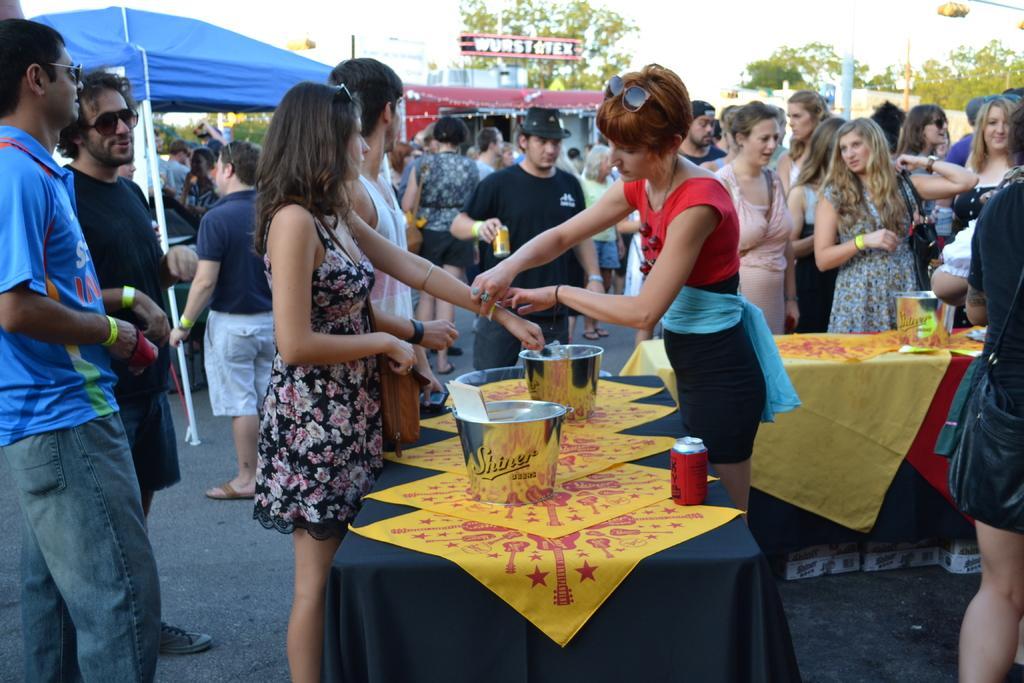Describe this image in one or two sentences. In this image in the front there is a table, on the table there are buckets and there is a tin can and there are persons standing and walking. In the background there is a tent which is blue in colour, there are trees, poles, there is a board with some text written on it and there are houses and and at the top we can see sky. 